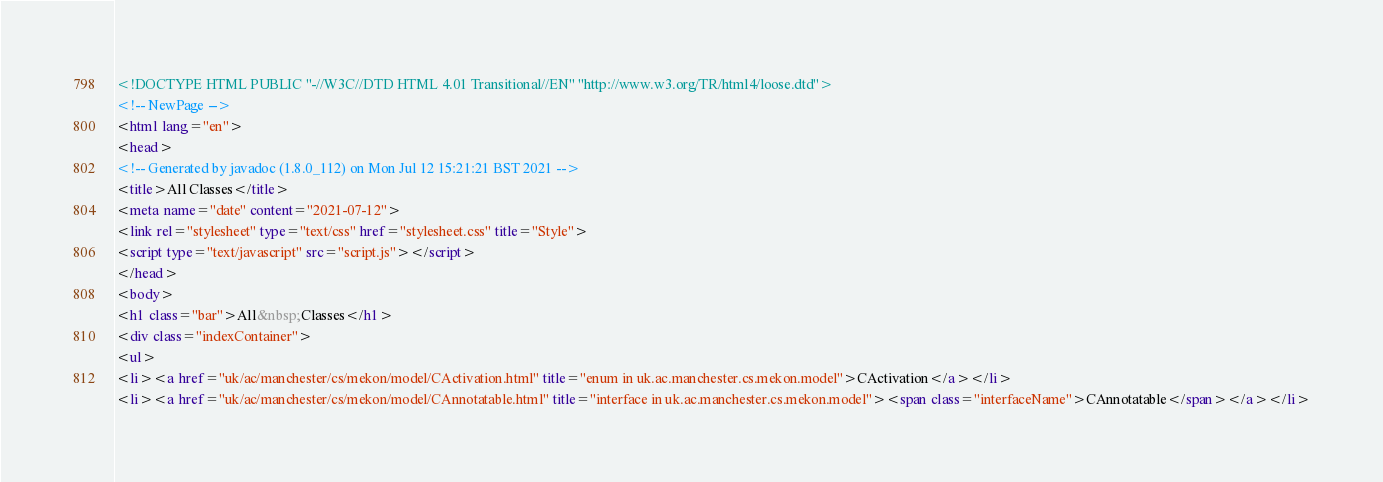<code> <loc_0><loc_0><loc_500><loc_500><_HTML_><!DOCTYPE HTML PUBLIC "-//W3C//DTD HTML 4.01 Transitional//EN" "http://www.w3.org/TR/html4/loose.dtd">
<!-- NewPage -->
<html lang="en">
<head>
<!-- Generated by javadoc (1.8.0_112) on Mon Jul 12 15:21:21 BST 2021 -->
<title>All Classes</title>
<meta name="date" content="2021-07-12">
<link rel="stylesheet" type="text/css" href="stylesheet.css" title="Style">
<script type="text/javascript" src="script.js"></script>
</head>
<body>
<h1 class="bar">All&nbsp;Classes</h1>
<div class="indexContainer">
<ul>
<li><a href="uk/ac/manchester/cs/mekon/model/CActivation.html" title="enum in uk.ac.manchester.cs.mekon.model">CActivation</a></li>
<li><a href="uk/ac/manchester/cs/mekon/model/CAnnotatable.html" title="interface in uk.ac.manchester.cs.mekon.model"><span class="interfaceName">CAnnotatable</span></a></li></code> 